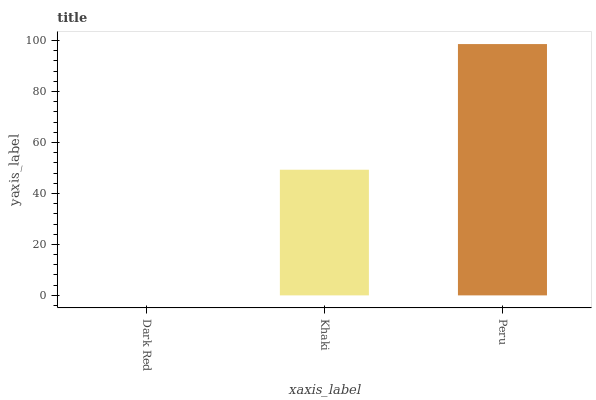Is Dark Red the minimum?
Answer yes or no. Yes. Is Peru the maximum?
Answer yes or no. Yes. Is Khaki the minimum?
Answer yes or no. No. Is Khaki the maximum?
Answer yes or no. No. Is Khaki greater than Dark Red?
Answer yes or no. Yes. Is Dark Red less than Khaki?
Answer yes or no. Yes. Is Dark Red greater than Khaki?
Answer yes or no. No. Is Khaki less than Dark Red?
Answer yes or no. No. Is Khaki the high median?
Answer yes or no. Yes. Is Khaki the low median?
Answer yes or no. Yes. Is Dark Red the high median?
Answer yes or no. No. Is Dark Red the low median?
Answer yes or no. No. 